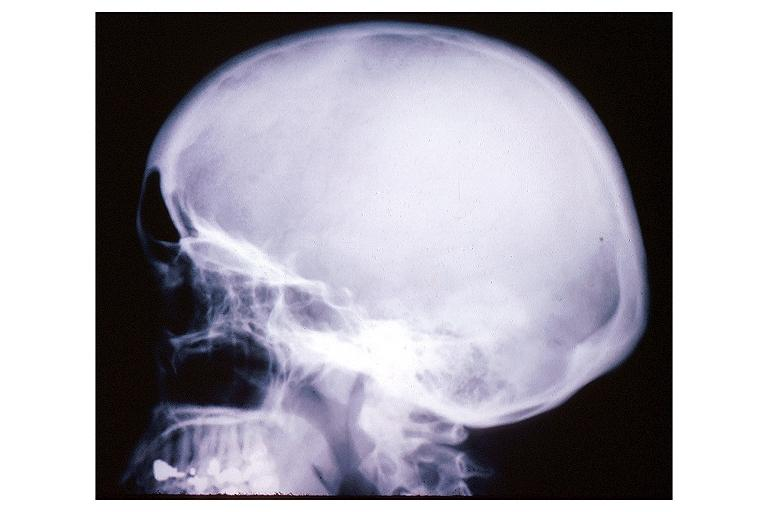s appendix present?
Answer the question using a single word or phrase. No 